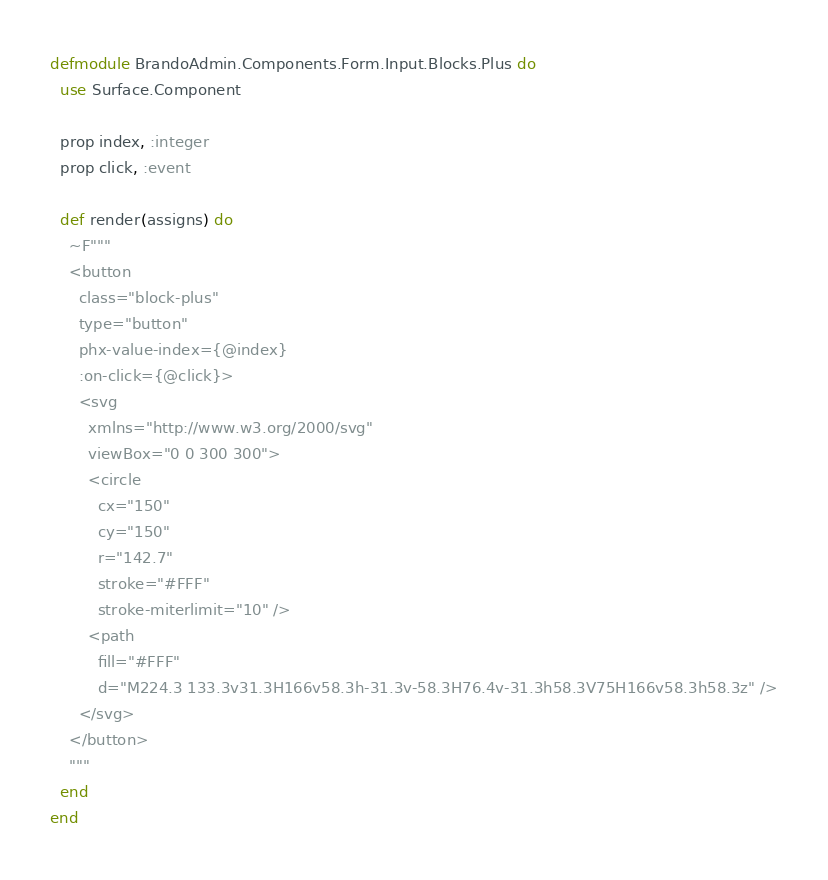<code> <loc_0><loc_0><loc_500><loc_500><_Elixir_>defmodule BrandoAdmin.Components.Form.Input.Blocks.Plus do
  use Surface.Component

  prop index, :integer
  prop click, :event

  def render(assigns) do
    ~F"""
    <button
      class="block-plus"
      type="button"
      phx-value-index={@index}
      :on-click={@click}>
      <svg
        xmlns="http://www.w3.org/2000/svg"
        viewBox="0 0 300 300">
        <circle
          cx="150"
          cy="150"
          r="142.7"
          stroke="#FFF"
          stroke-miterlimit="10" />
        <path
          fill="#FFF"
          d="M224.3 133.3v31.3H166v58.3h-31.3v-58.3H76.4v-31.3h58.3V75H166v58.3h58.3z" />
      </svg>
    </button>
    """
  end
end
</code> 